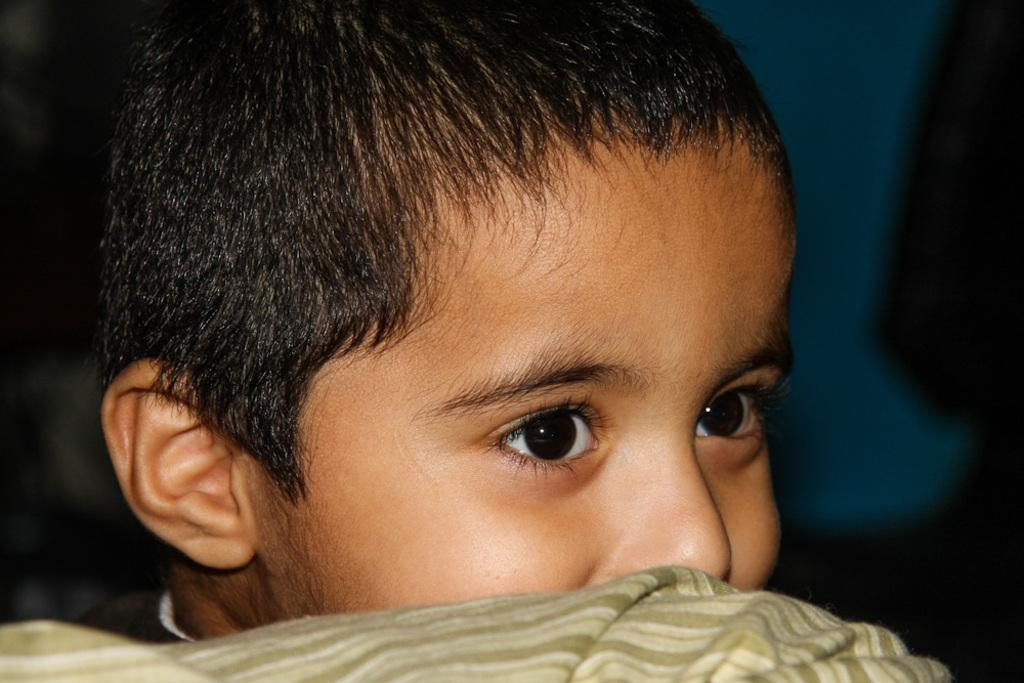What is the main subject of the image? The main subject of the image is a kid's face. Can you describe the background of the image? The background of the image is blurred, and it is blue in color. What type of fruit can be seen in the crate in the image? There is no crate or fruit present in the image; it only contains a kid's face and a blue, blurred background. 